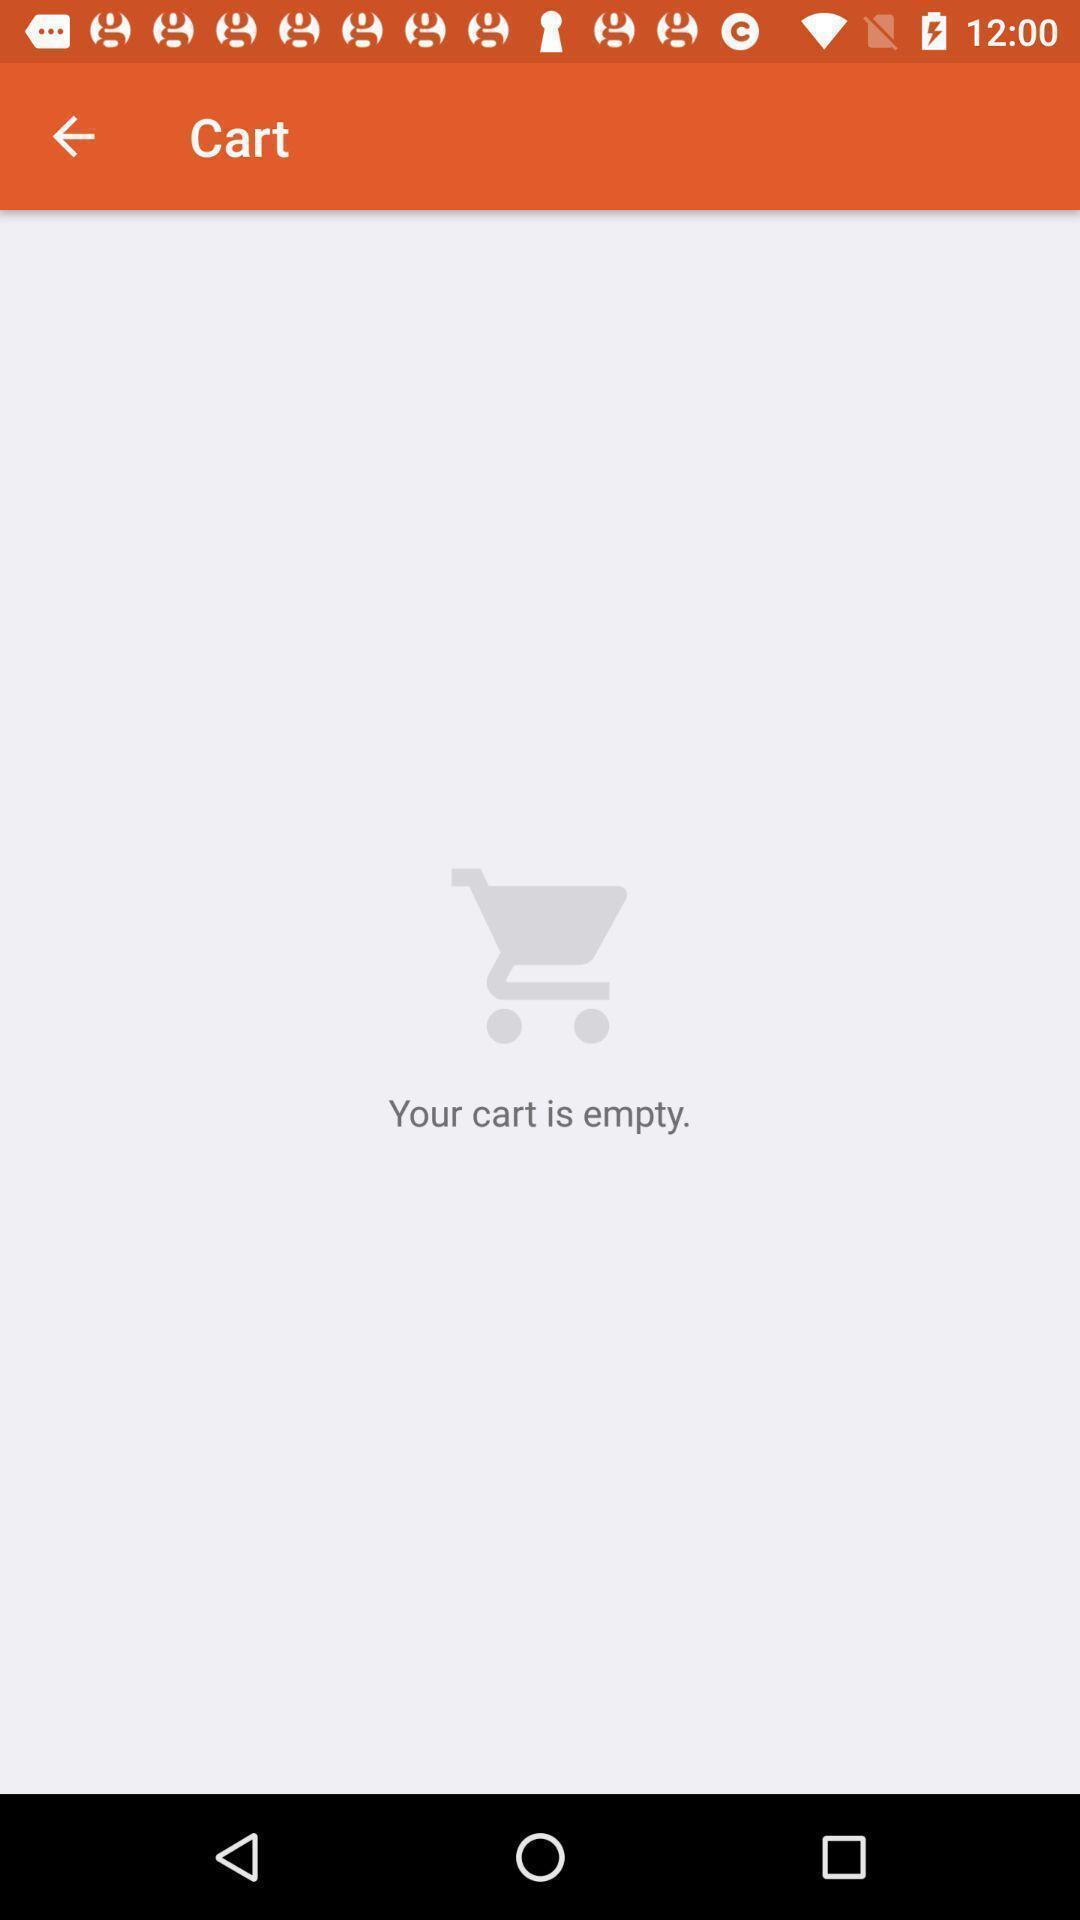Give me a narrative description of this picture. Screen shows cart details in a shopping application. 